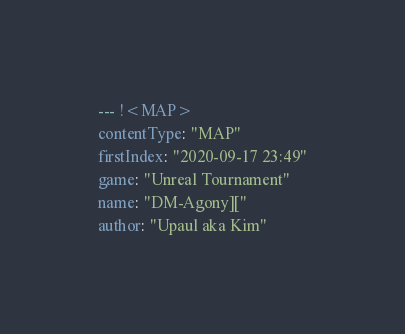<code> <loc_0><loc_0><loc_500><loc_500><_YAML_>--- !<MAP>
contentType: "MAP"
firstIndex: "2020-09-17 23:49"
game: "Unreal Tournament"
name: "DM-Agony]["
author: "Upaul aka Kim"</code> 